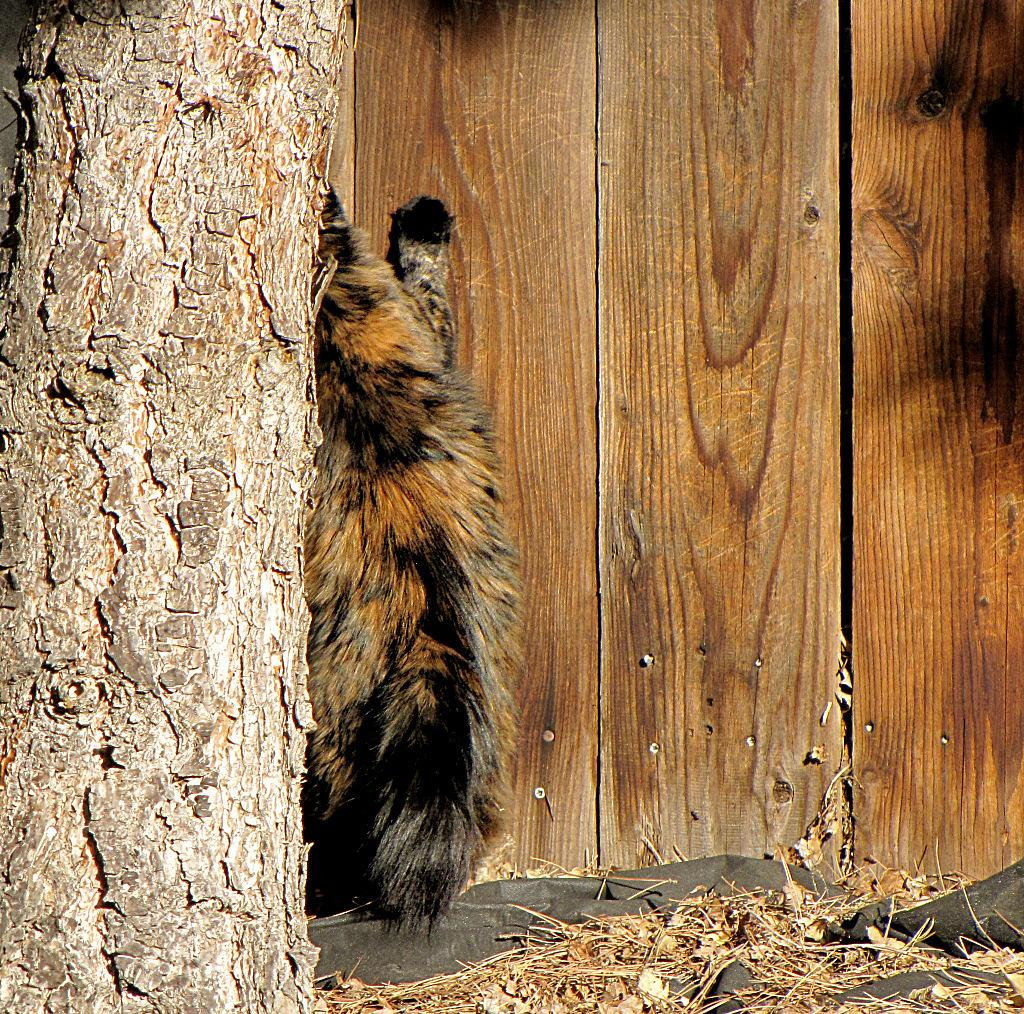What is the main subject in the center of the image? There is an animal in the center of the image. What can be seen on the left side of the image? There is a tree on the left side of the image. What type of structure is visible in the background of the image? There is a wooden wall in the background of the image. How many slaves are visible in the image? There are no slaves present in the image. What type of lettuce is growing near the tree in the image? There is no lettuce present in the image. 